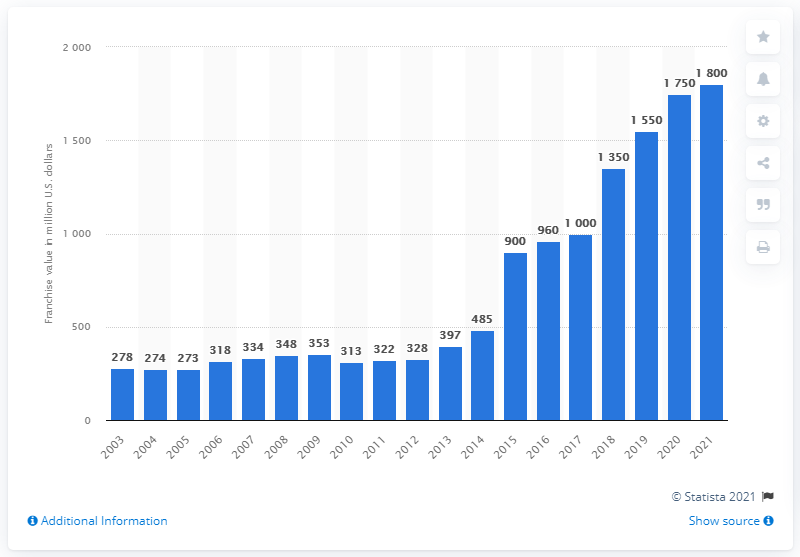Point out several critical features in this image. In 2021, the estimated value of the Washington Wizards was $1.8 billion. 